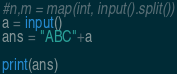<code> <loc_0><loc_0><loc_500><loc_500><_Python_>#n,m = map(int, input().split())
a = input()
ans = "ABC"+a

print(ans)
</code> 